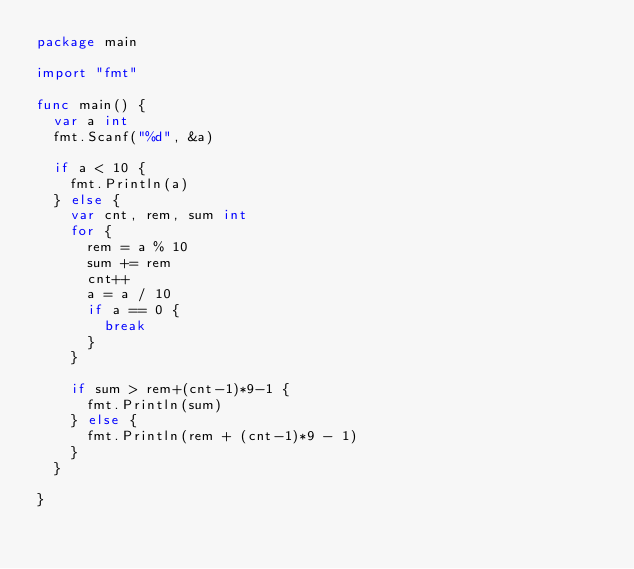Convert code to text. <code><loc_0><loc_0><loc_500><loc_500><_Go_>package main

import "fmt"

func main() {
	var a int
	fmt.Scanf("%d", &a)

	if a < 10 {
		fmt.Println(a)
	} else {
		var cnt, rem, sum int
		for {
			rem = a % 10
			sum += rem
			cnt++
			a = a / 10
			if a == 0 {
				break
			}
		}

		if sum > rem+(cnt-1)*9-1 {
			fmt.Println(sum)
		} else {
			fmt.Println(rem + (cnt-1)*9 - 1)
		}
	}

}
</code> 